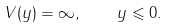<formula> <loc_0><loc_0><loc_500><loc_500>V ( y ) = \infty , \quad y \leqslant 0 .</formula> 